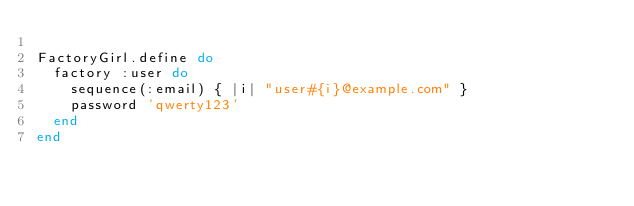<code> <loc_0><loc_0><loc_500><loc_500><_Ruby_>
FactoryGirl.define do
  factory :user do
    sequence(:email) { |i| "user#{i}@example.com" }
    password 'qwerty123'
  end
end
</code> 